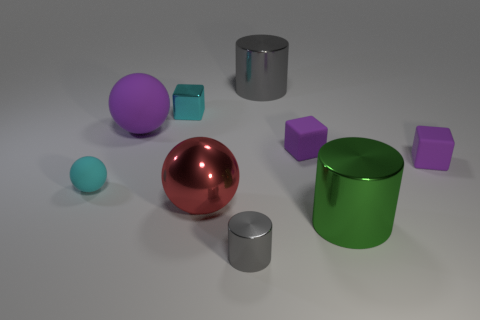Subtract all cylinders. How many objects are left? 6 Subtract 0 brown cylinders. How many objects are left? 9 Subtract all objects. Subtract all small purple metal objects. How many objects are left? 0 Add 2 large matte things. How many large matte things are left? 3 Add 6 large shiny cylinders. How many large shiny cylinders exist? 8 